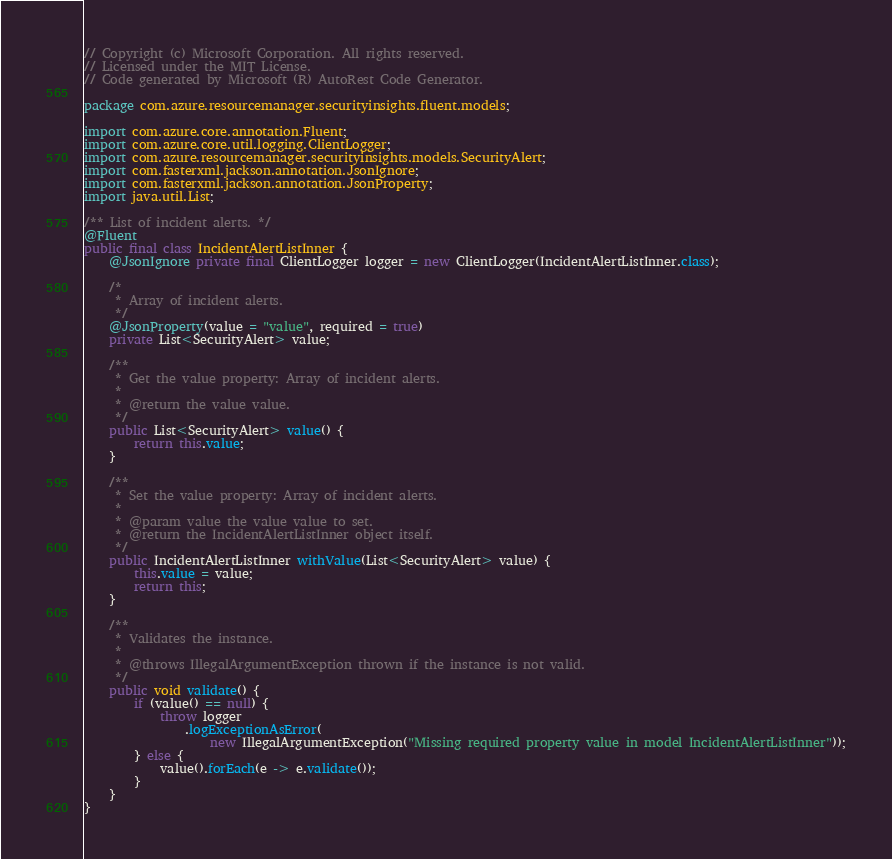Convert code to text. <code><loc_0><loc_0><loc_500><loc_500><_Java_>// Copyright (c) Microsoft Corporation. All rights reserved.
// Licensed under the MIT License.
// Code generated by Microsoft (R) AutoRest Code Generator.

package com.azure.resourcemanager.securityinsights.fluent.models;

import com.azure.core.annotation.Fluent;
import com.azure.core.util.logging.ClientLogger;
import com.azure.resourcemanager.securityinsights.models.SecurityAlert;
import com.fasterxml.jackson.annotation.JsonIgnore;
import com.fasterxml.jackson.annotation.JsonProperty;
import java.util.List;

/** List of incident alerts. */
@Fluent
public final class IncidentAlertListInner {
    @JsonIgnore private final ClientLogger logger = new ClientLogger(IncidentAlertListInner.class);

    /*
     * Array of incident alerts.
     */
    @JsonProperty(value = "value", required = true)
    private List<SecurityAlert> value;

    /**
     * Get the value property: Array of incident alerts.
     *
     * @return the value value.
     */
    public List<SecurityAlert> value() {
        return this.value;
    }

    /**
     * Set the value property: Array of incident alerts.
     *
     * @param value the value value to set.
     * @return the IncidentAlertListInner object itself.
     */
    public IncidentAlertListInner withValue(List<SecurityAlert> value) {
        this.value = value;
        return this;
    }

    /**
     * Validates the instance.
     *
     * @throws IllegalArgumentException thrown if the instance is not valid.
     */
    public void validate() {
        if (value() == null) {
            throw logger
                .logExceptionAsError(
                    new IllegalArgumentException("Missing required property value in model IncidentAlertListInner"));
        } else {
            value().forEach(e -> e.validate());
        }
    }
}
</code> 